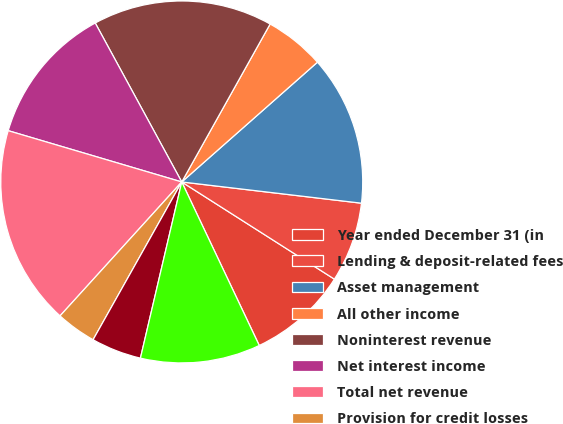Convert chart to OTSL. <chart><loc_0><loc_0><loc_500><loc_500><pie_chart><fcel>Year ended December 31 (in<fcel>Lending & deposit-related fees<fcel>Asset management<fcel>All other income<fcel>Noninterest revenue<fcel>Net interest income<fcel>Total net revenue<fcel>Provision for credit losses<fcel>Credit reimbursement to IB (a)<fcel>Compensation expense<nl><fcel>8.93%<fcel>7.15%<fcel>13.38%<fcel>5.37%<fcel>16.05%<fcel>12.49%<fcel>17.83%<fcel>3.59%<fcel>4.48%<fcel>10.71%<nl></chart> 